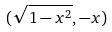Convert formula to latex. <formula><loc_0><loc_0><loc_500><loc_500>( \sqrt { 1 - x ^ { 2 } } , - x )</formula> 